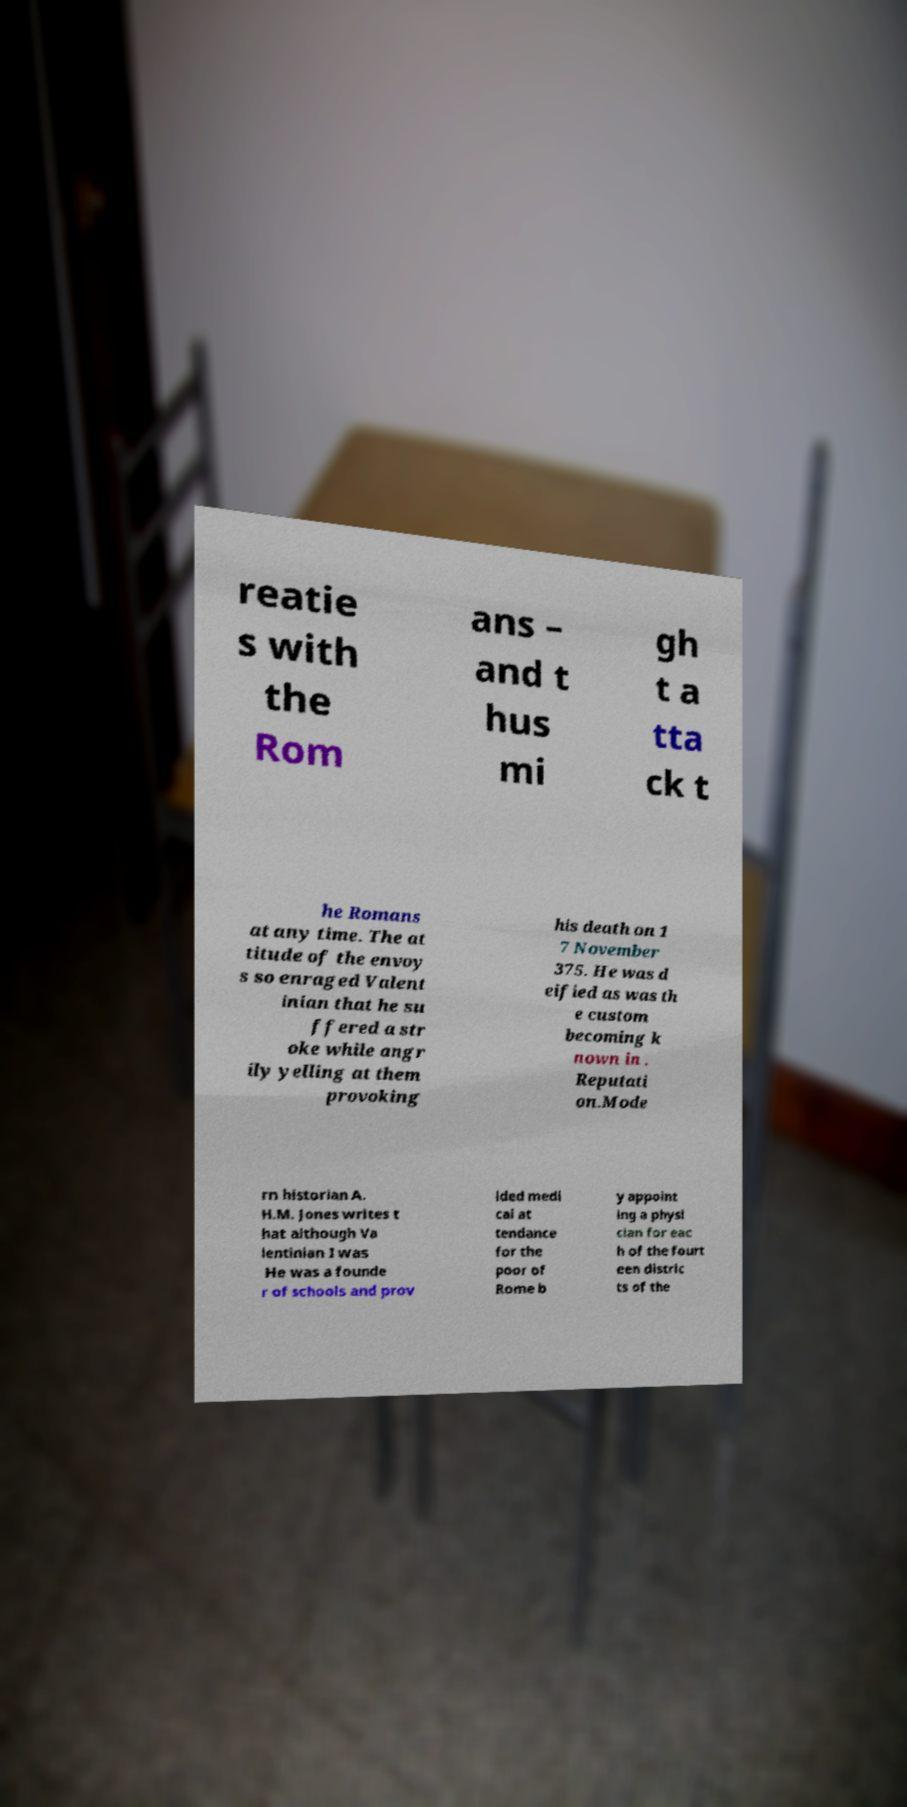I need the written content from this picture converted into text. Can you do that? reatie s with the Rom ans – and t hus mi gh t a tta ck t he Romans at any time. The at titude of the envoy s so enraged Valent inian that he su ffered a str oke while angr ily yelling at them provoking his death on 1 7 November 375. He was d eified as was th e custom becoming k nown in . Reputati on.Mode rn historian A. H.M. Jones writes t hat although Va lentinian I was He was a founde r of schools and prov ided medi cal at tendance for the poor of Rome b y appoint ing a physi cian for eac h of the fourt een distric ts of the 